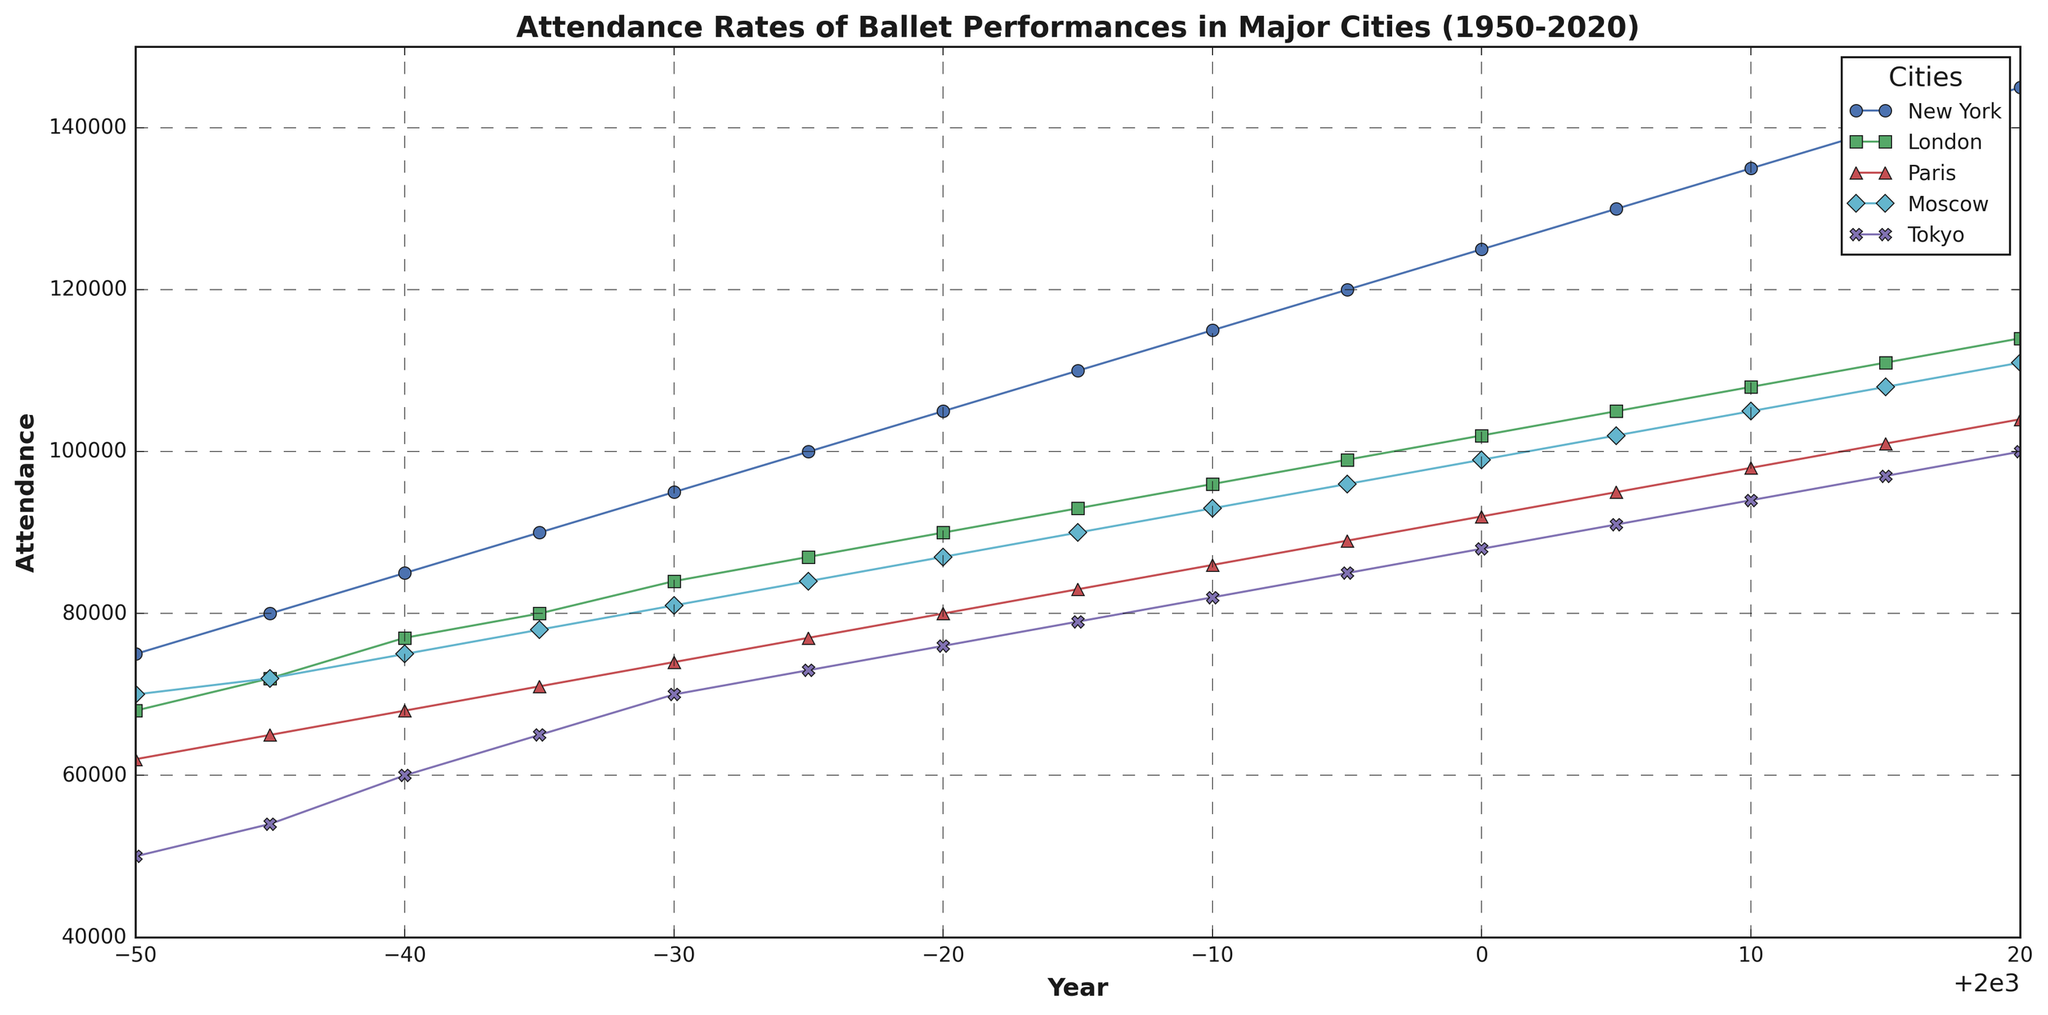Which city had the highest attendance in 2020? Looking at the end of the lines in 2020, New York had the highest attendance since its line ends at the highest point on the y-axis.
Answer: New York Which city showed the greatest increase in attendance from 1950 to 2020? Calculate the difference in attendance for each city between 1950 and 2020. New York increased from 75,000 to 145,000, a difference of 70,000; London from 68,000 to 114,000, a difference of 46,000; Paris from 62,000 to 104,000, a difference of 42,000; Moscow from 70,000 to 111,000, a difference of 41,000; Tokyo from 50,000 to 100,000, a difference of 50,000. New York had the biggest increase of 70,000.
Answer: New York Which two cities have almost identical attendance rates every year? By visually aligning the lines for different cities, Moscow and Paris have closely aligned lines, indicating similar attendance rates each year.
Answer: Moscow and Paris What was the average attendance for Tokyo from 1950 to 2020? Calculate the mean of Tokyo's attendance over the years: (50,000 + 54,000 + 60,000 + 65,000 + 70,000 + 73,000 + 76,000 + 79,000 + 82,000 + 85,000 + 88,000 + 91,000 + 94,000 + 97,000 + 100,000) / 15 ≈ 73,933.33.
Answer: 73,933.33 How did New York's attendance change between 1980 and 1990? New York's attendance in 1980 was 105,000 and in 1990 was 115,000. The change is 115,000 - 105,000 = 10,000.
Answer: Increased by 10,000 Which city had the lowest attendance in the initial year, 1950? Observing the starting points of all the lines in 1950, Tokyo had the lowest attendance as its line is lowest on the y-axis for that year.
Answer: Tokyo During which decade did London experience the largest growth in attendance? Compare the increase in London's attendance per decade: 1950-1960 (6,000), 1960-1970 (7,000), 1970-1980 (6,000), 1980-1990 (6,000), 1990-2000 (6,000), 2000-2010 (6,000), 2010-2020 (6,000). The largest growth of 7,000 occurred between 1960 and 1970.
Answer: 1960 to 1970 